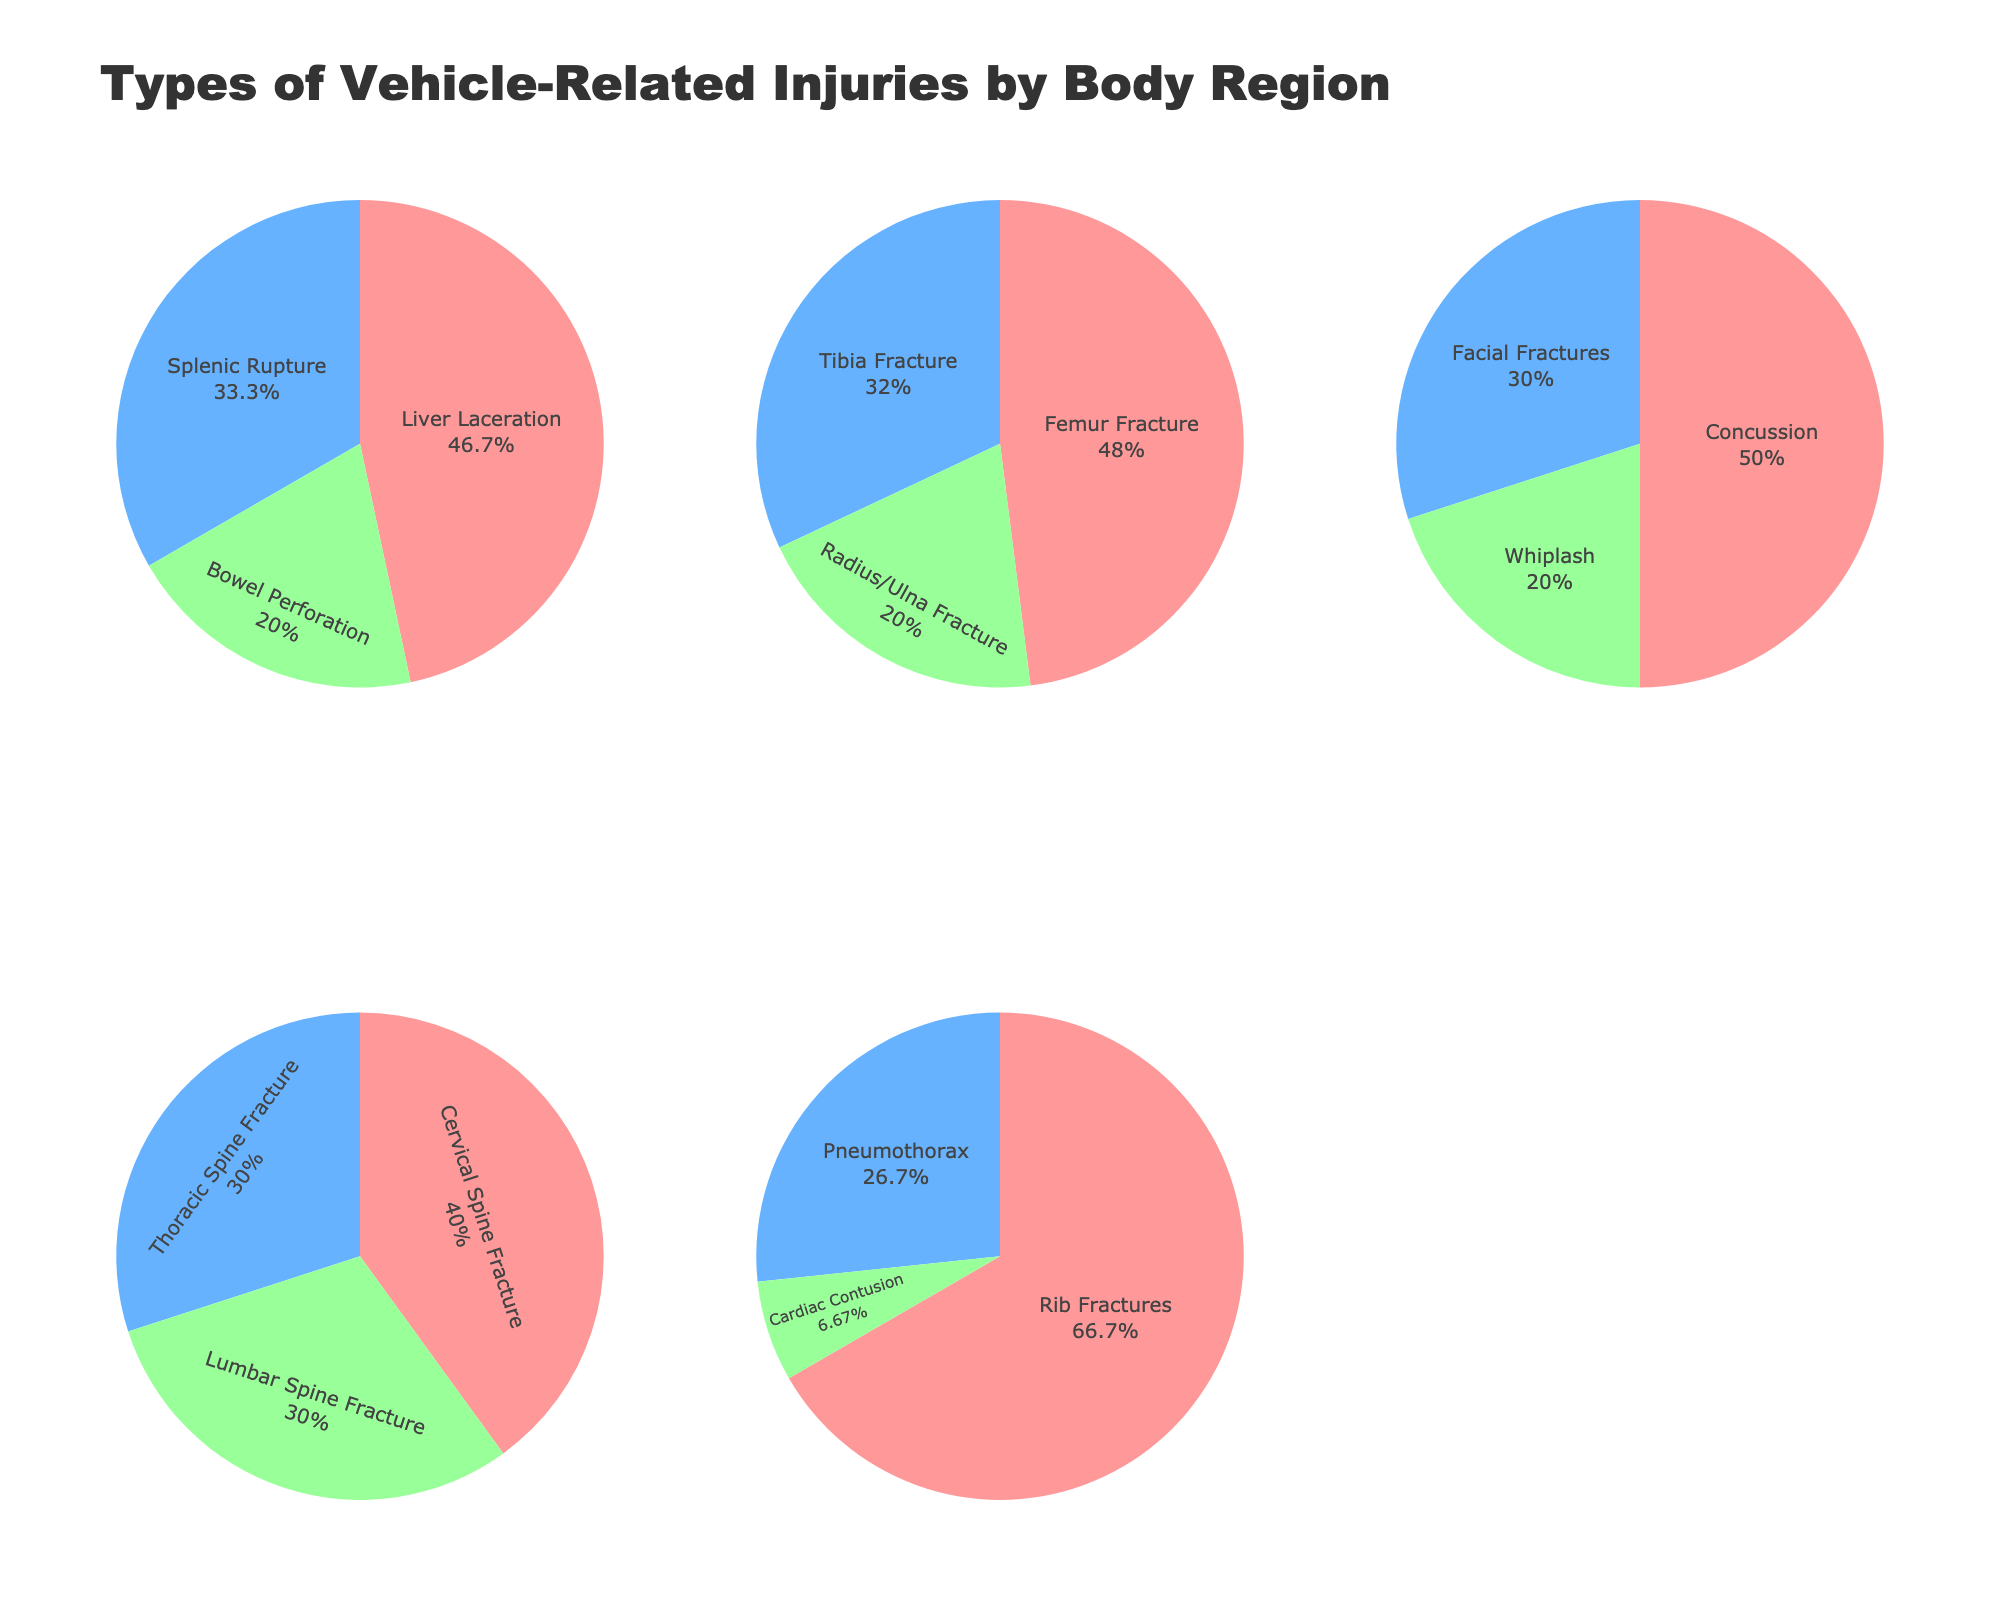What are the injury types for the Head and Neck region? In the figure, the pie chart for "Head and Neck" indicates three injury types by their labels: Concussion, Facial Fractures, and Whiplash.
Answer: Concussion, Facial Fractures, Whiplash Which body region has the highest percentage of a single injury type? By looking at all the pie charts, the "Head and Neck" region has the highest percentage for a single injury type, with "Concussion" making up 25% of injuries.
Answer: Head and Neck (Concussion, 25%) How many injury types are categorized for the Abdomen region? The "Abdomen" pie chart shows three labels: Liver Laceration, Splenic Rupture, and Bowel Perforation.
Answer: 3 What is the total percentage of thoracic injuries? Adding the percentages from the "Thorax" pie chart: Rib Fractures (20) + Pneumothorax (8) + Cardiac Contusion (2) = 30%.
Answer: 30% Which diagram shows the most varied distribution of injury types? The pie chart for "Thorax" shows the most uniform distribution with the percentages being 20%, 8%, and 2%, indicating varied distribution compared to others like "Head and Neck" with one dominant 25%.
Answer: Thorax Is the percentage of Femur Fractures greater than that of Rib Fractures? Checking the pie charts for "Extremities" and "Thorax": Femur Fractures (12%) is less than Rib Fractures (20%).
Answer: No Are there more types of injuries to the Spine or Abdomen? The "Spine" pie chart has three types: Cervical Spine Fracture, Thoracic Spine Fracture, Lumbar Spine Fracture. The "Abdomen" pie chart also has three types: Liver Laceration, Splenic Rupture, Bowel Perforation, so they are equal.
Answer: Equal What's the cumulative percentage for the most common injuries in Extremities and Spine regions? The most common injuries are Femur Fracture (12%) for Extremities, and Cervical Spine Fracture (4%) for Spine. Adding these gives: 12 + 4 = 16%.
Answer: 16% What is the least common injury type in the Thorax region? The "Thorax" chart shows Rib Fractures (20%), Pneumothorax (8%), and Cardiac Contusion (2%). The least common is Cardiac Contusion at 2%.
Answer: Cardiac Contusion (2%) Which regions have injury types with percentages less than 5%? By examining all pie charts: "Thorax" with Cardiac Contusion (2%), "Abdomen" with Bowel Perforation (3%), and "Spine" with all three types (Cervical, Thoracic, and Lumbar Spine Fractures, each 3% or 4%) have percentages less than 5%.
Answer: Thorax, Abdomen, Spine 